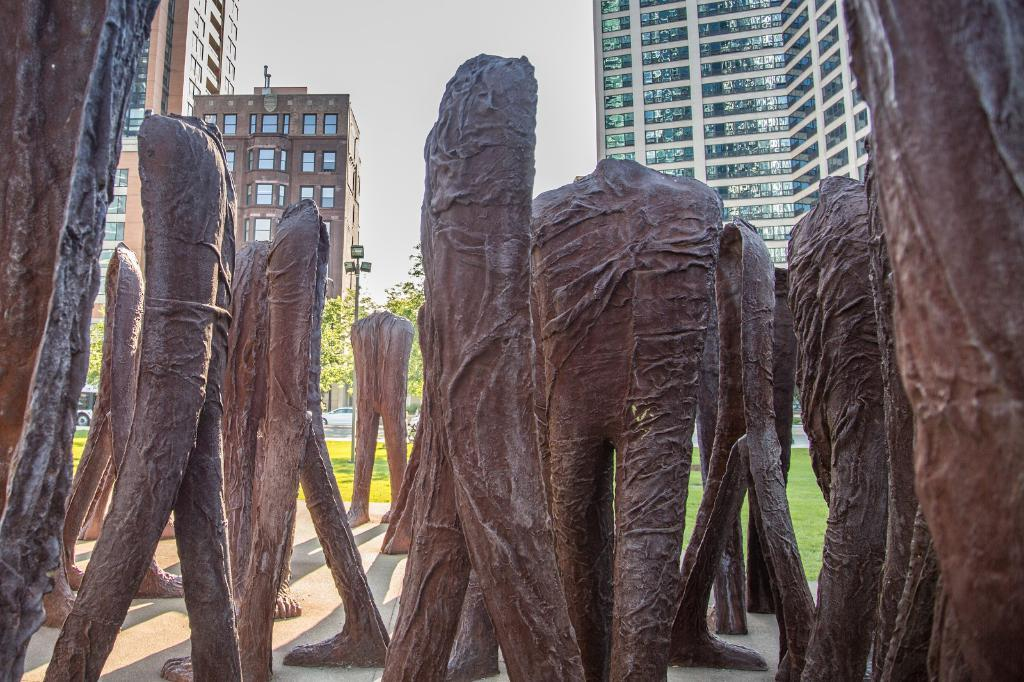What can be seen in the image that represents human-made art? There are statues in the image. Where are the statues located? The statues are located in a park. What can be seen in the background of the image? There are trees, a street light, at least one building, and cars visible in the background. What is visible at the top of the image? The sky is visible at the top of the image. What can be observed in the sky? Clouds are present in the sky. What type of produce is being sold by the doctor in the image? There is no doctor or produce present in the image. How many snails can be seen crawling on the statues in the image? There are no snails visible on the statues in the image. 